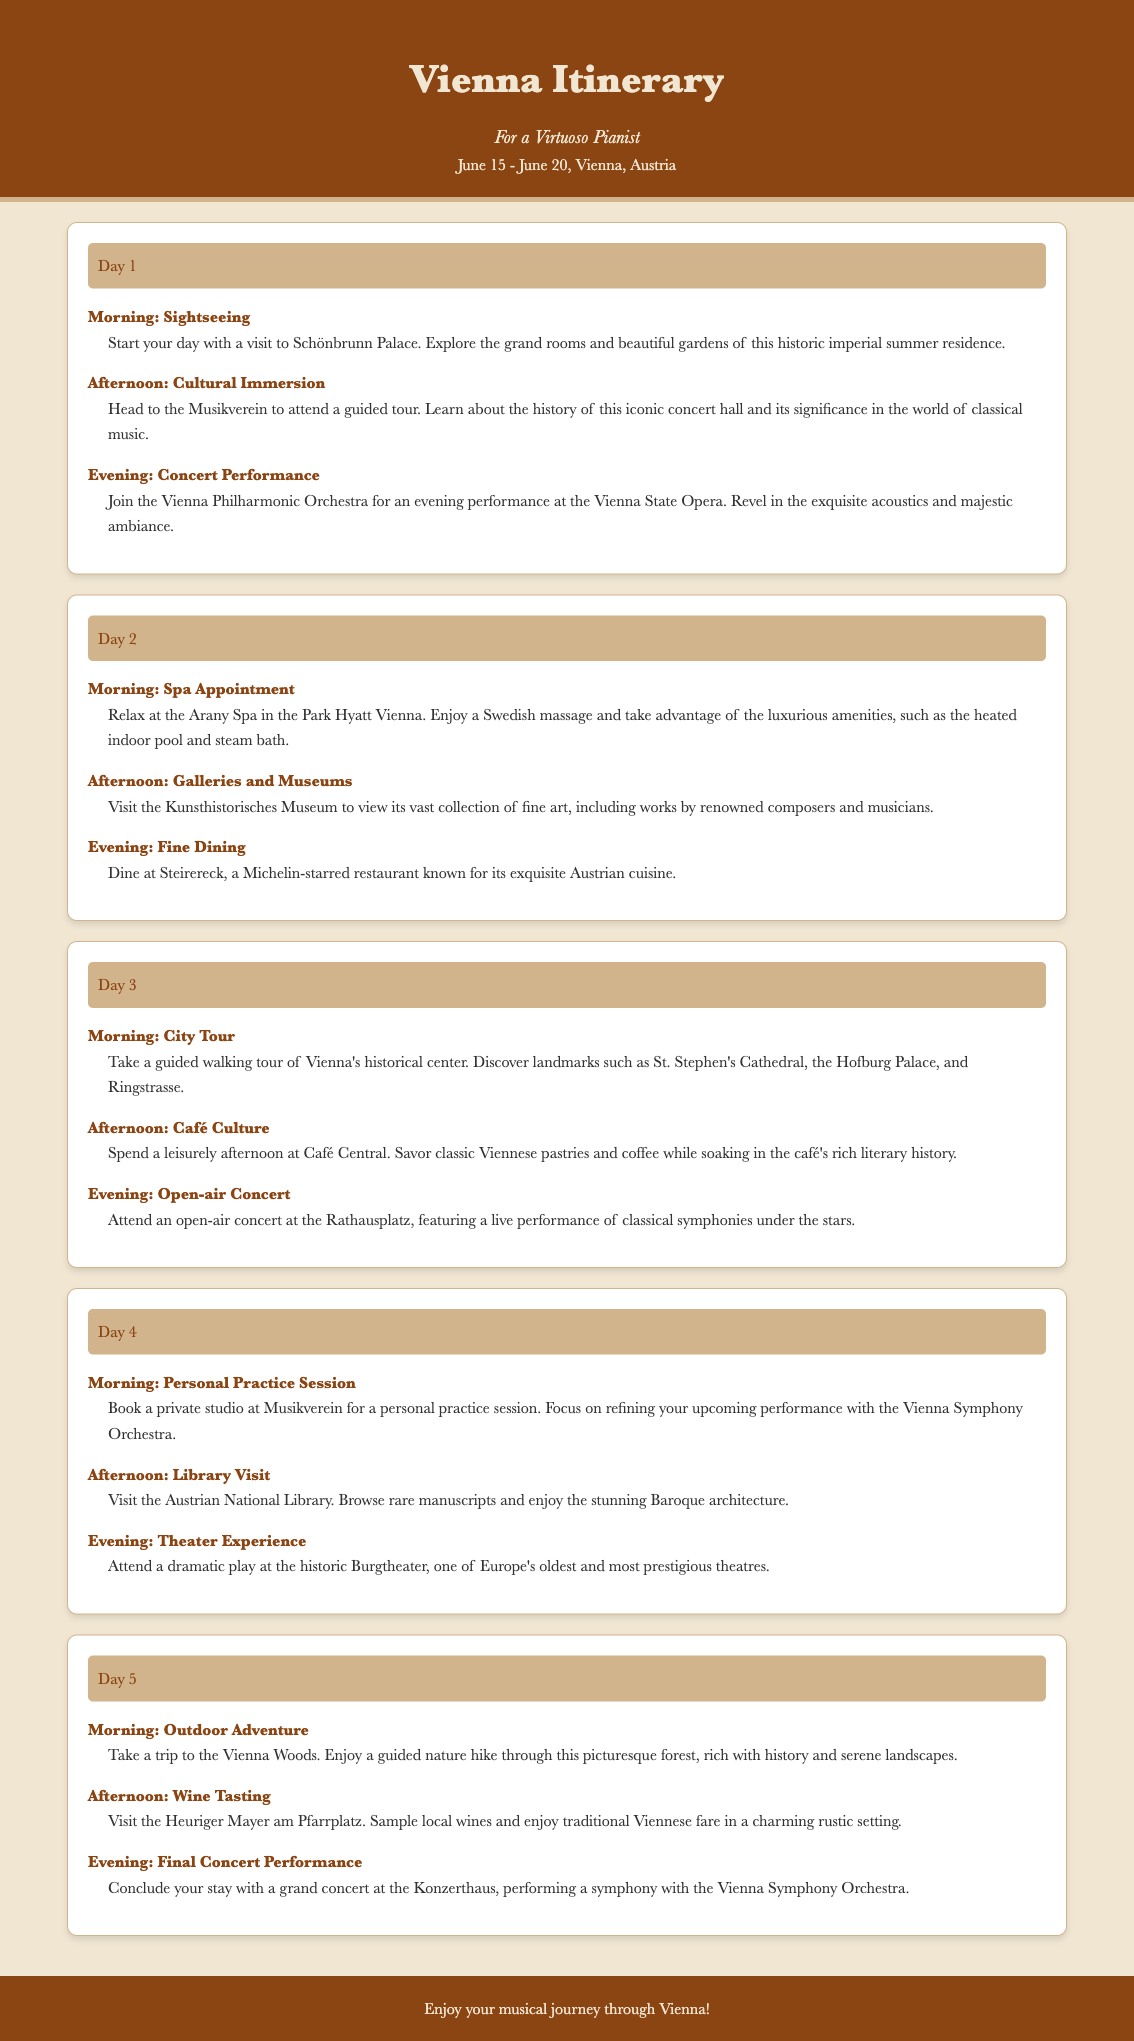What is the title of the itinerary? The title of the itinerary is prominently displayed at the top of the document.
Answer: Vienna Itinerary What is included in the Day 2 morning activity? The Day 2 morning activity is detailed, mentioning specific services at a location.
Answer: Spa Appointment Which restaurant is recommended for fine dining? The document specifies a particular restaurant known for its culinary excellence for the evening activity.
Answer: Steirereck How many days does the itinerary cover? The total number of days mentioned in the itinerary structure is counted.
Answer: 5 days What is the primary focus of the Day 4 afternoon activity? The Day 4 afternoon activity highlights a specific visitation experience relating to literature and history.
Answer: Library Visit Which orchestra is featured in the final concert performance? The document indicates the specific orchestra involved in the concluding event.
Answer: Vienna Symphony Orchestra What type of experience is emphasized on Day 3 afternoon? The Day 3 afternoon activity reflects a cultural aspect typical to the region, emphasizing relaxation and enjoyment.
Answer: Café Culture Where is the concert performance on Day 1 held? The location for the Day 1 evening performance is mentioned in relation to a prominent venue.
Answer: Vienna State Opera 